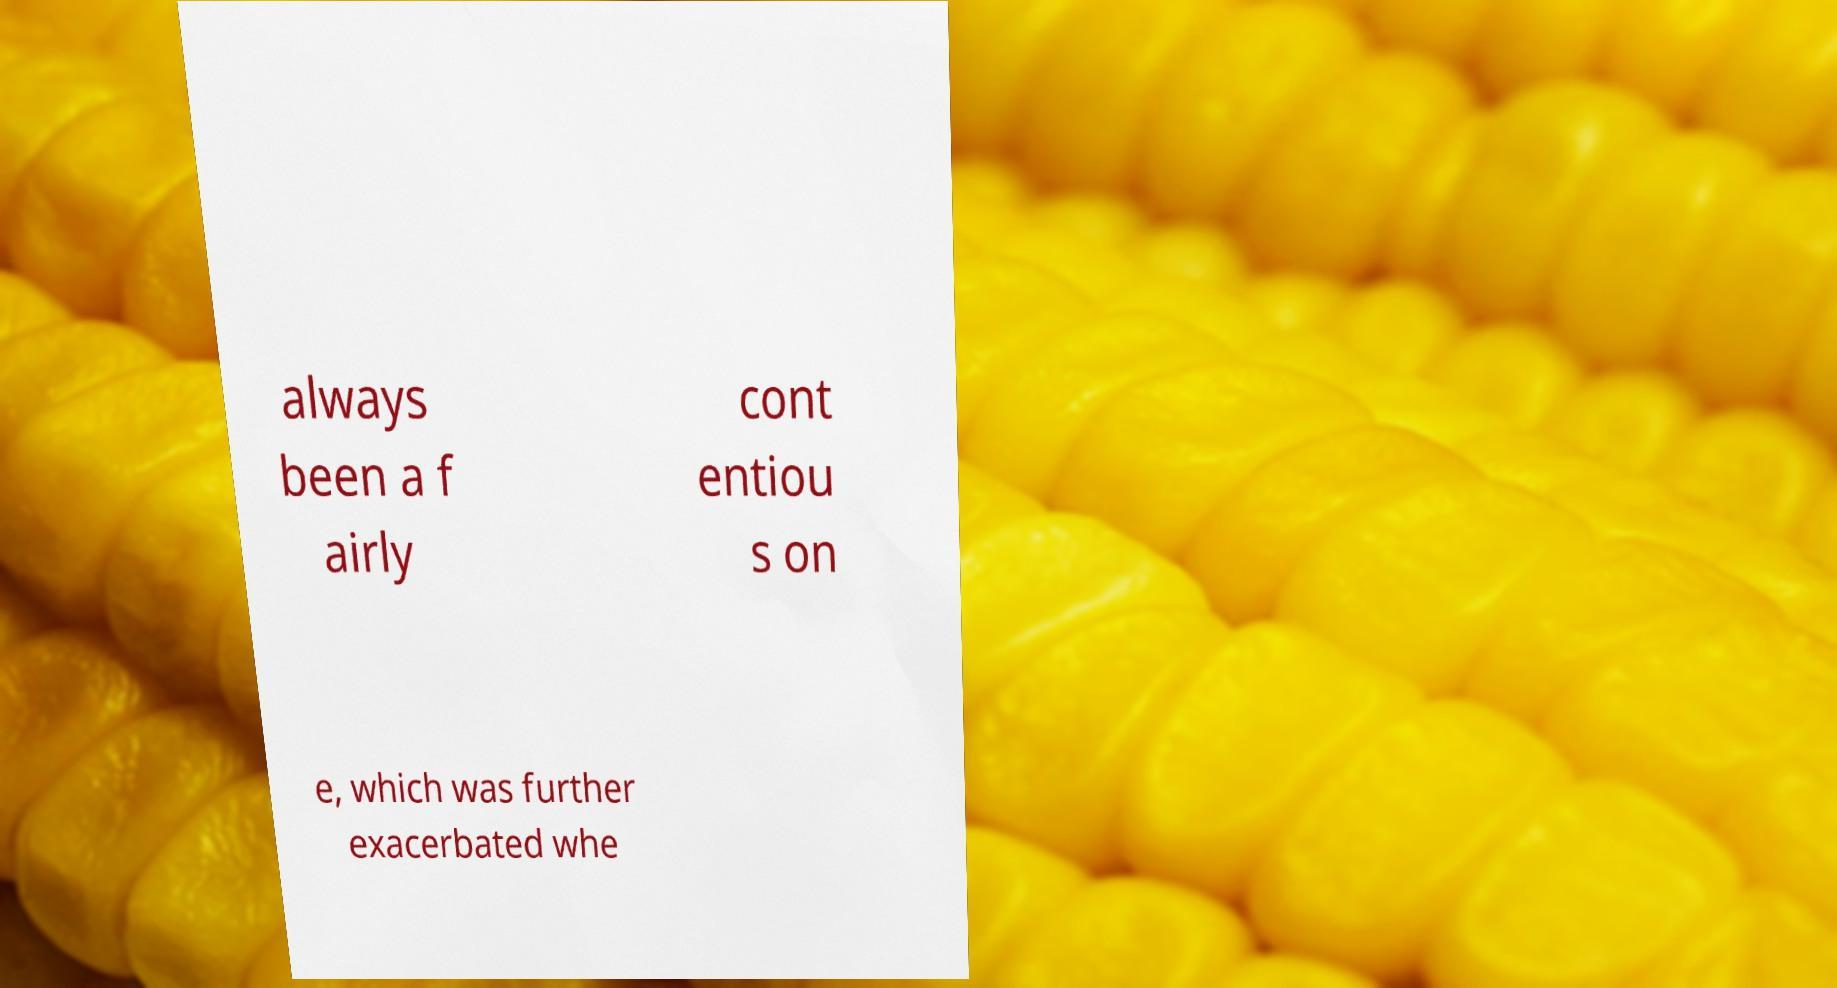I need the written content from this picture converted into text. Can you do that? always been a f airly cont entiou s on e, which was further exacerbated whe 